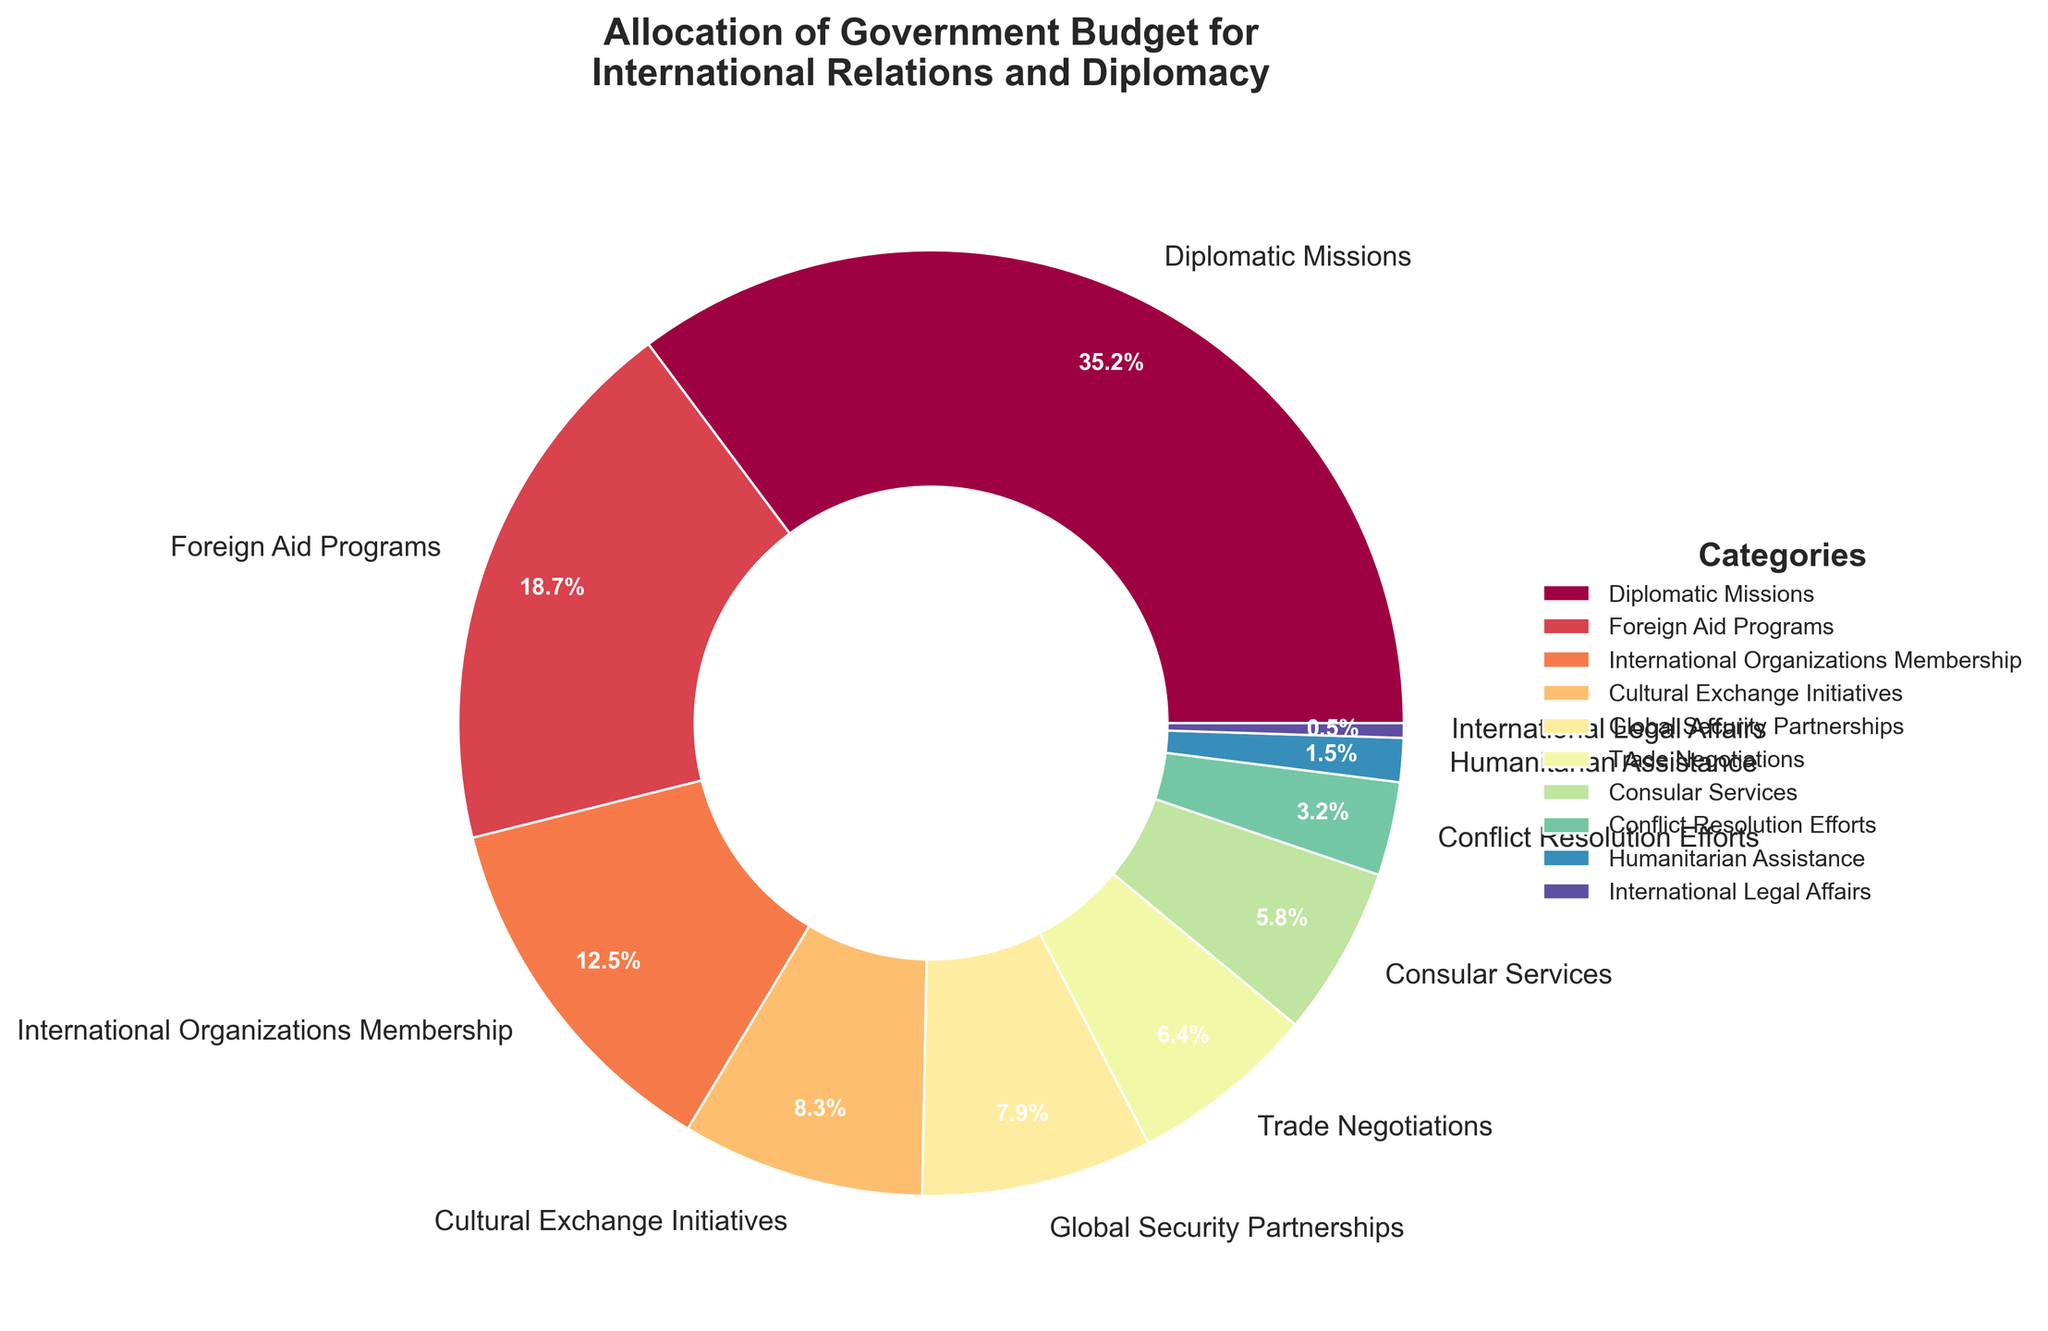Which category has the highest allocation? The pie chart shows that "Diplomatic Missions" occupies the largest section.
Answer: Diplomatic Missions Which category has the lowest allocation? The smallest section of the pie chart is labeled "International Legal Affairs".
Answer: International Legal Affairs How much more is allocated to Diplomatic Missions than International Organizations Membership? Diplomatic Missions is allocated 35.2% and International Organizations Membership is allocated 12.5%. The difference is 35.2% - 12.5% = 22.7%.
Answer: 22.7% What is the total percentage allocated to cultural initiatives and humanitarian efforts? Cultural Exchange Initiatives have 8.3% and Humanitarian Assistance has 1.5%. Adding these together, 8.3% + 1.5% = 9.8%.
Answer: 9.8% Which category receives more funding: Trade Negotiations or Global Security Partnerships? Trade Negotiations have 6.4% and Global Security Partnerships have 7.9%. Since 7.9% > 6.4%, Global Security Partnerships receive more funding.
Answer: Global Security Partnerships What combined percentage is allocated to Foreign Aid Programs, Conflict Resolution Efforts, and Humanitarian Assistance? Foreign Aid Programs are allocated 18.7%, Conflict Resolution Efforts have 3.2%, and Humanitarian Assistance has 1.5%. Summing these, 18.7% + 3.2% + 1.5% = 23.4%.
Answer: 23.4% How does the allocation for Consular Services compare to Cultural Exchange Initiatives? Consular Services have an allocation of 5.8% while Cultural Exchange Initiatives are at 8.3%. Since 8.3% > 5.8%, Cultural Exchange Initiatives receive more funding.
Answer: Cultural Exchange Initiatives What are the categories that each receive more than 10% of the budget? The categories are Diplomatic Missions (35.2%), Foreign Aid Programs (18.7%), and International Organizations Membership (12.5%) - all exceeding 10%.
Answer: Diplomatic Missions, Foreign Aid Programs, International Organizations Membership What's the percentage difference between allocations for Conflict Resolution Efforts and International Legal Affairs? Conflict Resolution Efforts have 3.2%, and International Legal Affairs have 0.5%. The difference is 3.2% - 0.5% = 2.7%.
Answer: 2.7% Which categories combined make up less than 10% of the total budget? Humanitarian Assistance has 1.5% and International Legal Affairs have 0.5%. Combined, they are 1.5% + 0.5% = 2.0%.
Answer: Humanitarian Assistance, International Legal Affairs 